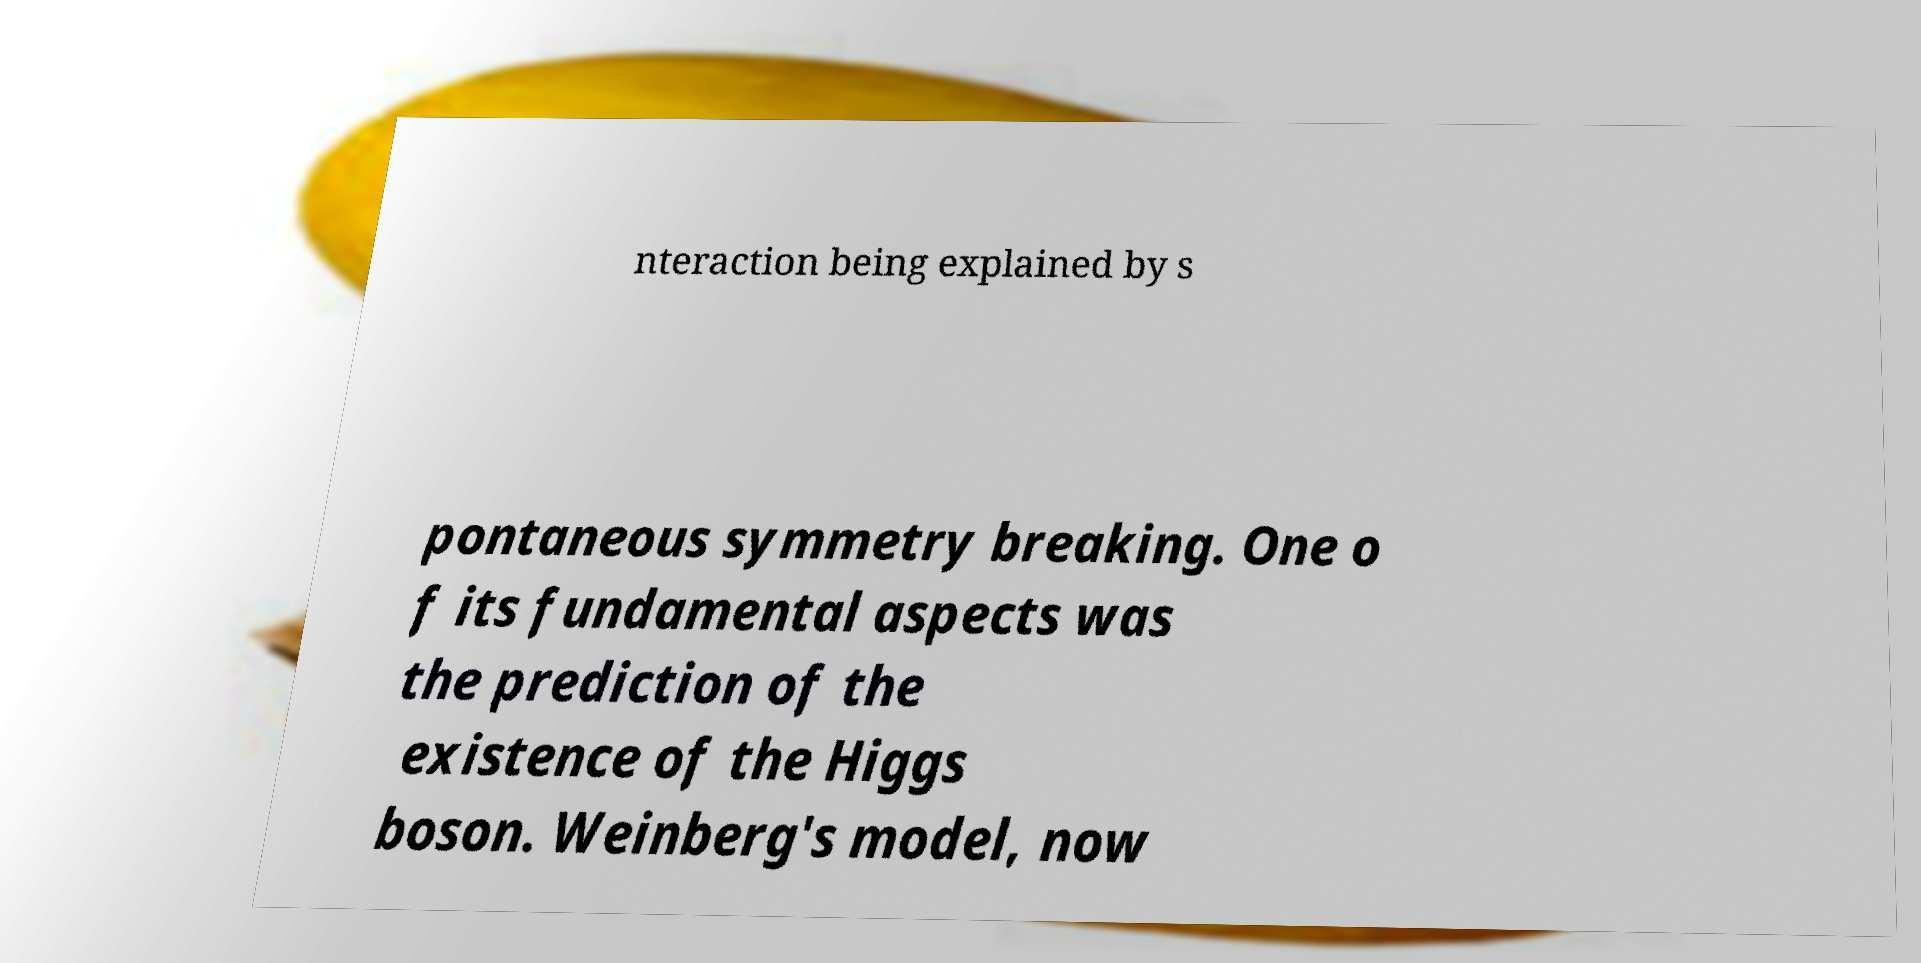I need the written content from this picture converted into text. Can you do that? nteraction being explained by s pontaneous symmetry breaking. One o f its fundamental aspects was the prediction of the existence of the Higgs boson. Weinberg's model, now 